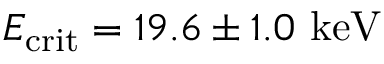<formula> <loc_0><loc_0><loc_500><loc_500>E _ { c r i t } = 1 9 . 6 \pm 1 . 0 k e V</formula> 